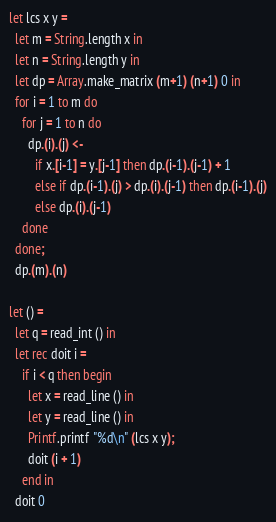<code> <loc_0><loc_0><loc_500><loc_500><_OCaml_>let lcs x y =
  let m = String.length x in
  let n = String.length y in
  let dp = Array.make_matrix (m+1) (n+1) 0 in
  for i = 1 to m do
    for j = 1 to n do
      dp.(i).(j) <-
        if x.[i-1] = y.[j-1] then dp.(i-1).(j-1) + 1
        else if dp.(i-1).(j) > dp.(i).(j-1) then dp.(i-1).(j)
        else dp.(i).(j-1)
    done
  done;
  dp.(m).(n)

let () =
  let q = read_int () in
  let rec doit i =
    if i < q then begin
      let x = read_line () in
      let y = read_line () in
      Printf.printf "%d\n" (lcs x y);
      doit (i + 1)
    end in
  doit 0</code> 